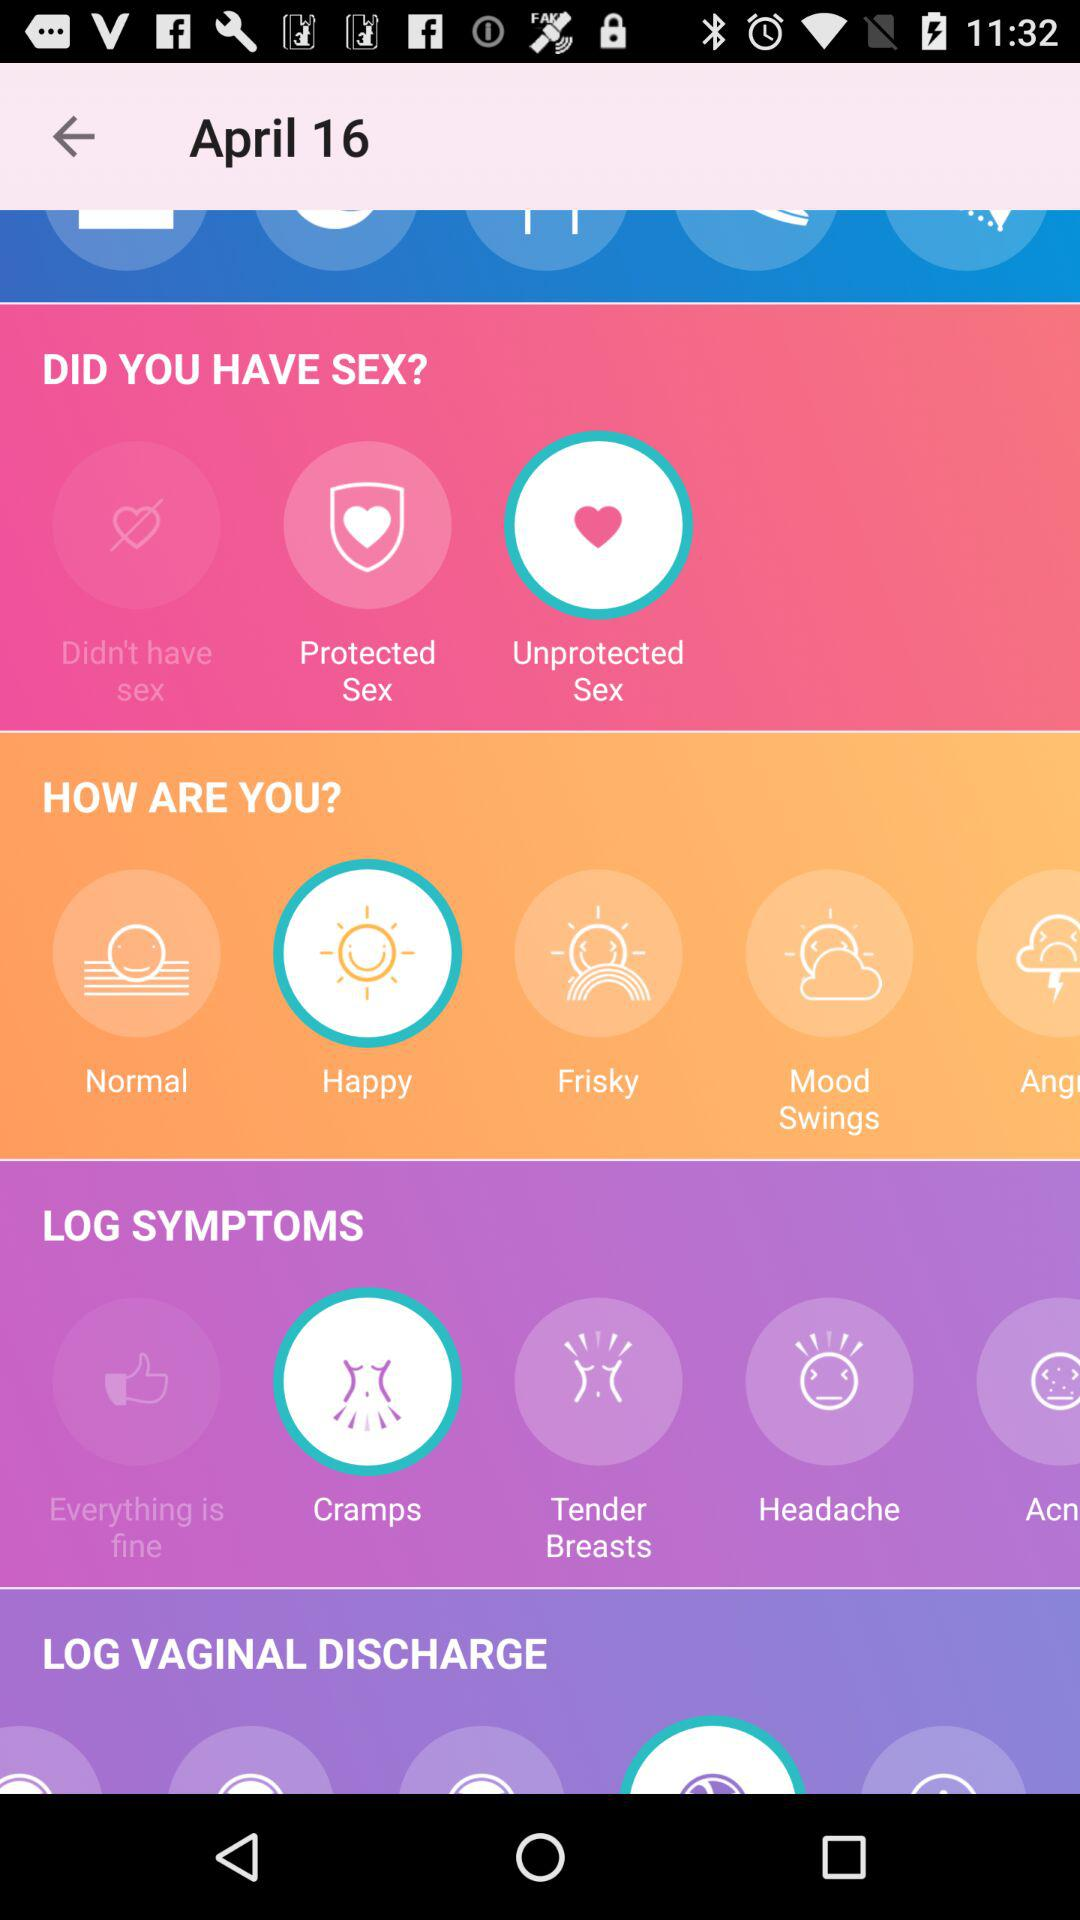What date is given? The given date is April 16. 